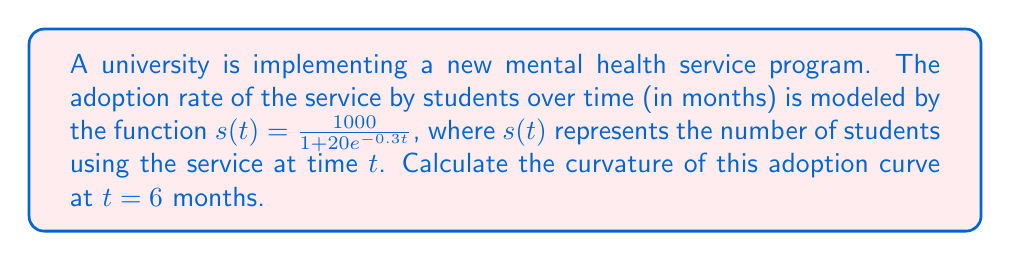Can you answer this question? To calculate the curvature of the adoption curve, we'll use the formula for curvature of a planar curve:

$$\kappa = \frac{|s''(t)|}{(1 + (s'(t))^2)^{3/2}}$$

Step 1: Calculate $s'(t)$
$$s'(t) = \frac{1000 \cdot 20 \cdot 0.3e^{-0.3t}}{(1 + 20e^{-0.3t})^2} = \frac{6000e^{-0.3t}}{(1 + 20e^{-0.3t})^2}$$

Step 2: Calculate $s''(t)$
$$s''(t) = \frac{-1800e^{-0.3t}(1 + 20e^{-0.3t})^2 + 24000e^{-0.6t}(1 + 20e^{-0.3t})}{(1 + 20e^{-0.3t})^4}$$

Step 3: Evaluate $s'(6)$ and $s''(6)$
$$s'(6) = \frac{6000e^{-1.8}}{(1 + 20e^{-1.8})^2} \approx 148.6498$$
$$s''(6) = \frac{-1800e^{-1.8}(1 + 20e^{-1.8})^2 + 24000e^{-3.6}(1 + 20e^{-1.8})}{(1 + 20e^{-1.8})^4} \approx -27.5670$$

Step 4: Calculate the curvature at $t = 6$
$$\kappa = \frac{|s''(6)|}{(1 + (s'(6))^2)^{3/2}} = \frac{27.5670}{(1 + 148.6498^2)^{3/2}} \approx 0.0012415$$
Answer: $\kappa \approx 0.0012415$ 